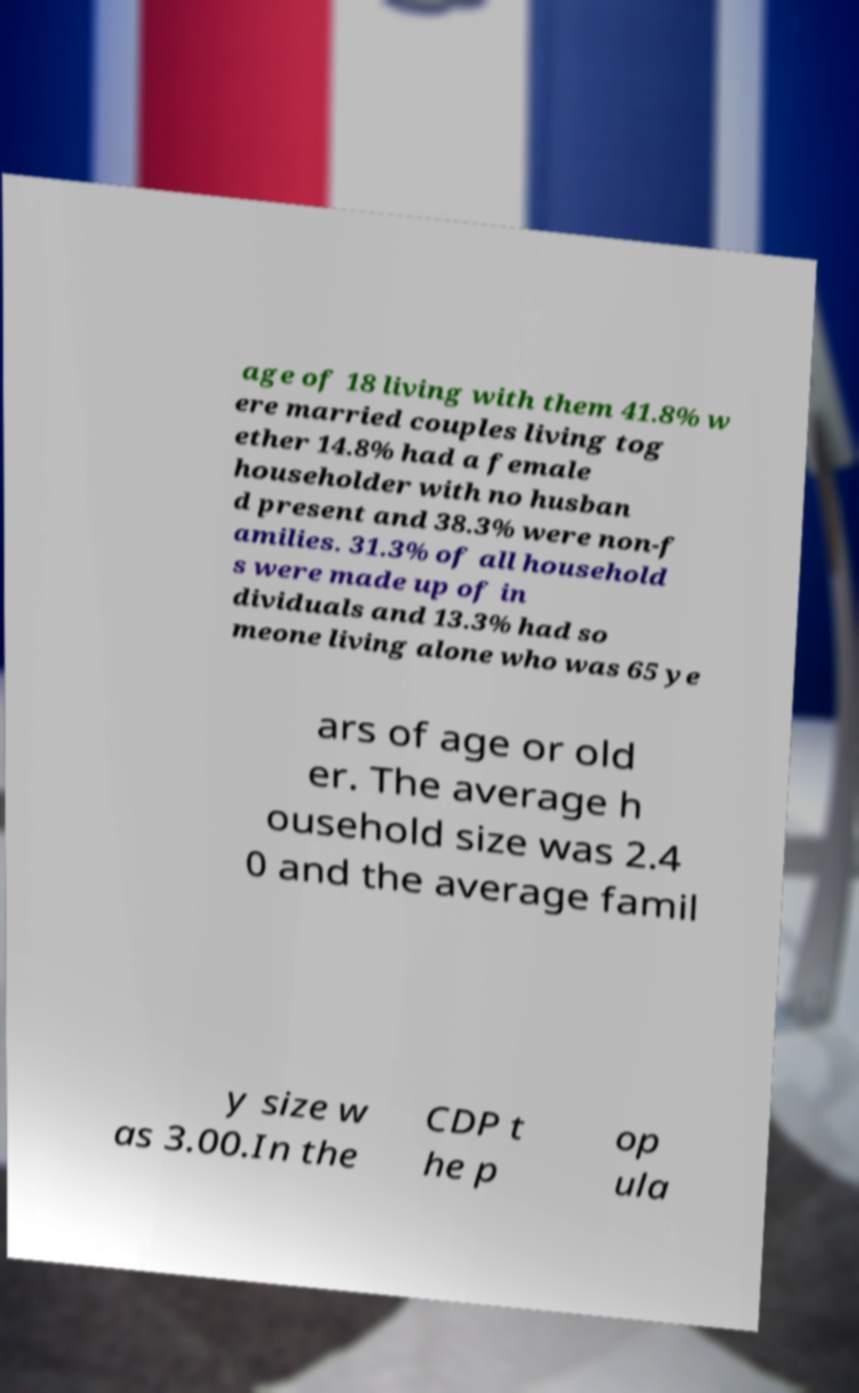Could you assist in decoding the text presented in this image and type it out clearly? age of 18 living with them 41.8% w ere married couples living tog ether 14.8% had a female householder with no husban d present and 38.3% were non-f amilies. 31.3% of all household s were made up of in dividuals and 13.3% had so meone living alone who was 65 ye ars of age or old er. The average h ousehold size was 2.4 0 and the average famil y size w as 3.00.In the CDP t he p op ula 